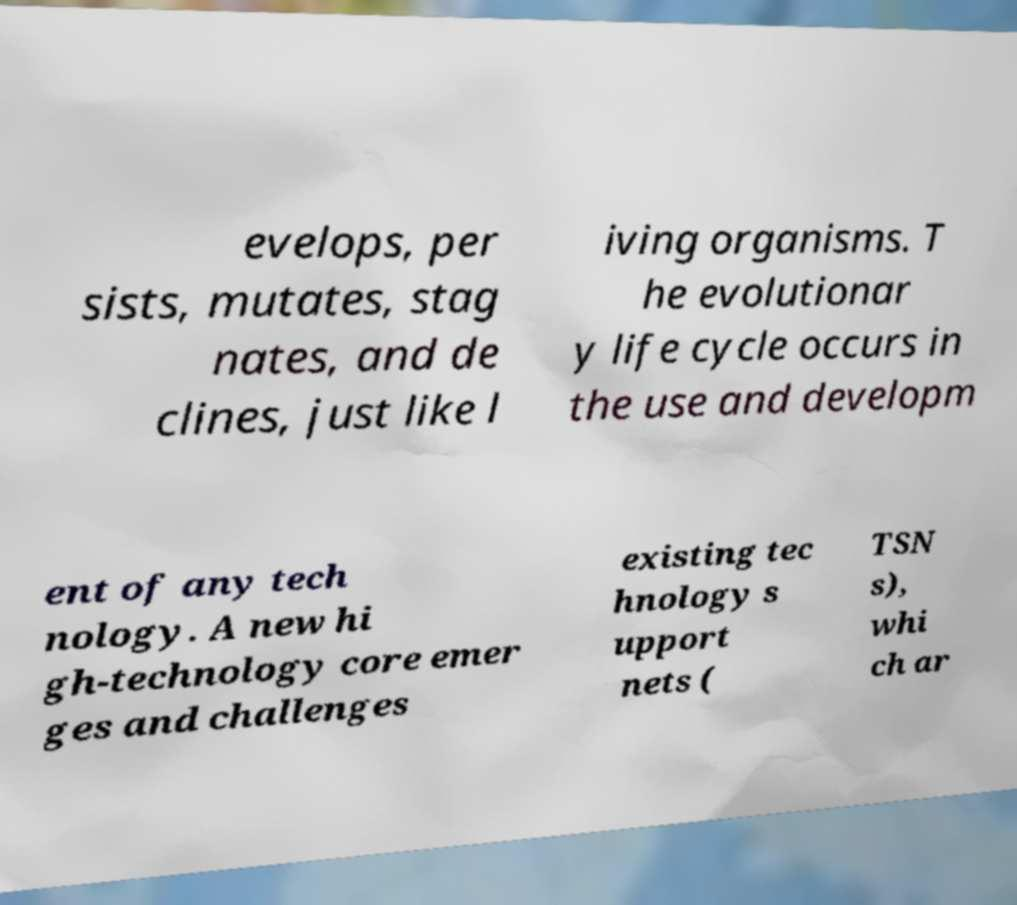Can you read and provide the text displayed in the image?This photo seems to have some interesting text. Can you extract and type it out for me? evelops, per sists, mutates, stag nates, and de clines, just like l iving organisms. T he evolutionar y life cycle occurs in the use and developm ent of any tech nology. A new hi gh-technology core emer ges and challenges existing tec hnology s upport nets ( TSN s), whi ch ar 